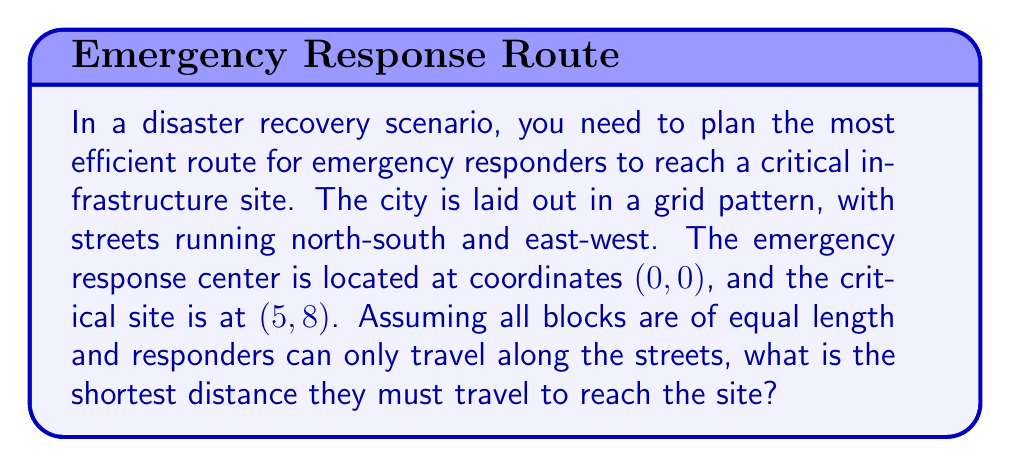Show me your answer to this math problem. To solve this problem, we need to understand the concept of Manhattan distance in a grid-like city layout. The Manhattan distance is the sum of the horizontal and vertical distances between two points.

Step 1: Identify the coordinates
- Starting point (emergency response center): (0, 0)
- Endpoint (critical infrastructure site): (5, 8)

Step 2: Calculate the horizontal distance
The horizontal distance is the absolute difference between the x-coordinates:
$$|x_2 - x_1| = |5 - 0| = 5$$

Step 3: Calculate the vertical distance
The vertical distance is the absolute difference between the y-coordinates:
$$|y_2 - y_1| = |8 - 0| = 8$$

Step 4: Sum the horizontal and vertical distances
The Manhattan distance is the sum of these two values:
$$\text{Manhattan Distance} = |x_2 - x_1| + |y_2 - y_1| = 5 + 8 = 13$$

This distance represents the shortest path the emergency responders can take along the city streets to reach the critical site.

[asy]
unitsize(0.5cm);
for(int i=0; i<=8; ++i) {
  draw((0,i)--(5,i),gray);
}
for(int i=0; i<=5; ++i) {
  draw((i,0)--(i,8),gray);
}
dot((0,0),red);
dot((5,8),blue);
draw((0,0)--(5,0)--(5,8),red+1);
label("(0,0)",(0,0),SW);
label("(5,8)",(5,8),NE);
label("5",((0+5)/2,0),S);
label("8",(5,(0+8)/2),E);
[/asy]

The red path in the diagram illustrates one of the possible shortest routes.
Answer: 13 units 